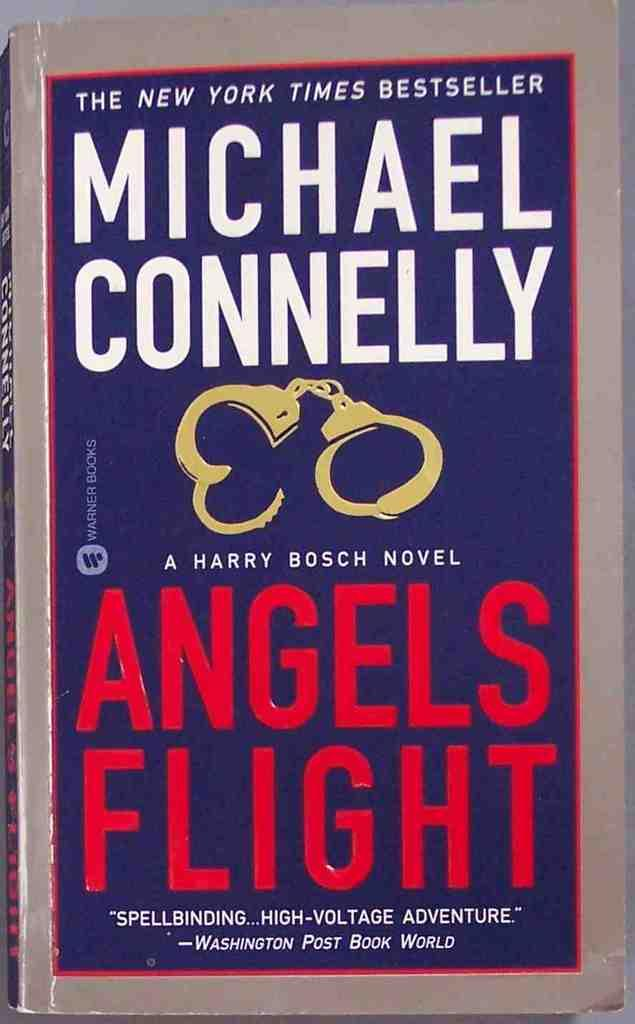<image>
Summarize the visual content of the image. A book by Michael Connelly called Angels Flight. 